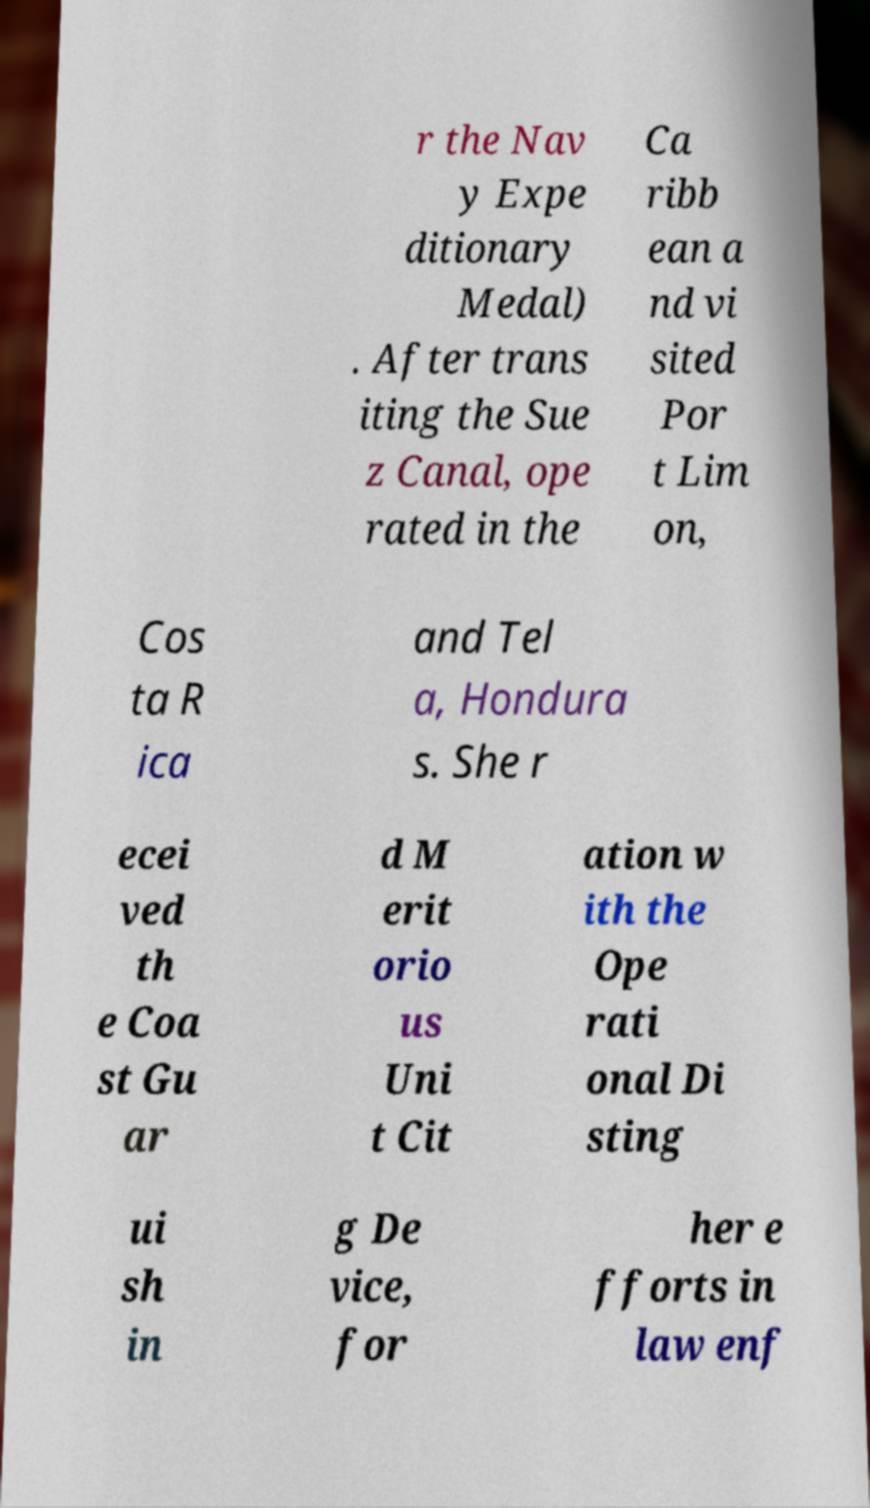Can you accurately transcribe the text from the provided image for me? r the Nav y Expe ditionary Medal) . After trans iting the Sue z Canal, ope rated in the Ca ribb ean a nd vi sited Por t Lim on, Cos ta R ica and Tel a, Hondura s. She r ecei ved th e Coa st Gu ar d M erit orio us Uni t Cit ation w ith the Ope rati onal Di sting ui sh in g De vice, for her e fforts in law enf 